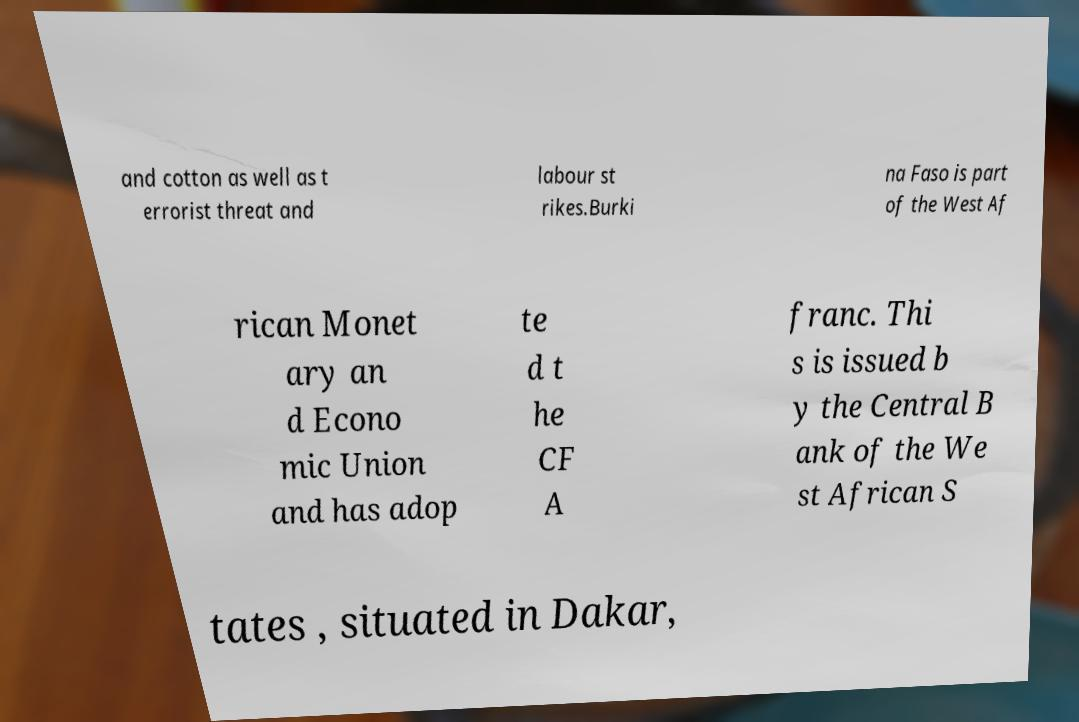Can you read and provide the text displayed in the image?This photo seems to have some interesting text. Can you extract and type it out for me? and cotton as well as t errorist threat and labour st rikes.Burki na Faso is part of the West Af rican Monet ary an d Econo mic Union and has adop te d t he CF A franc. Thi s is issued b y the Central B ank of the We st African S tates , situated in Dakar, 